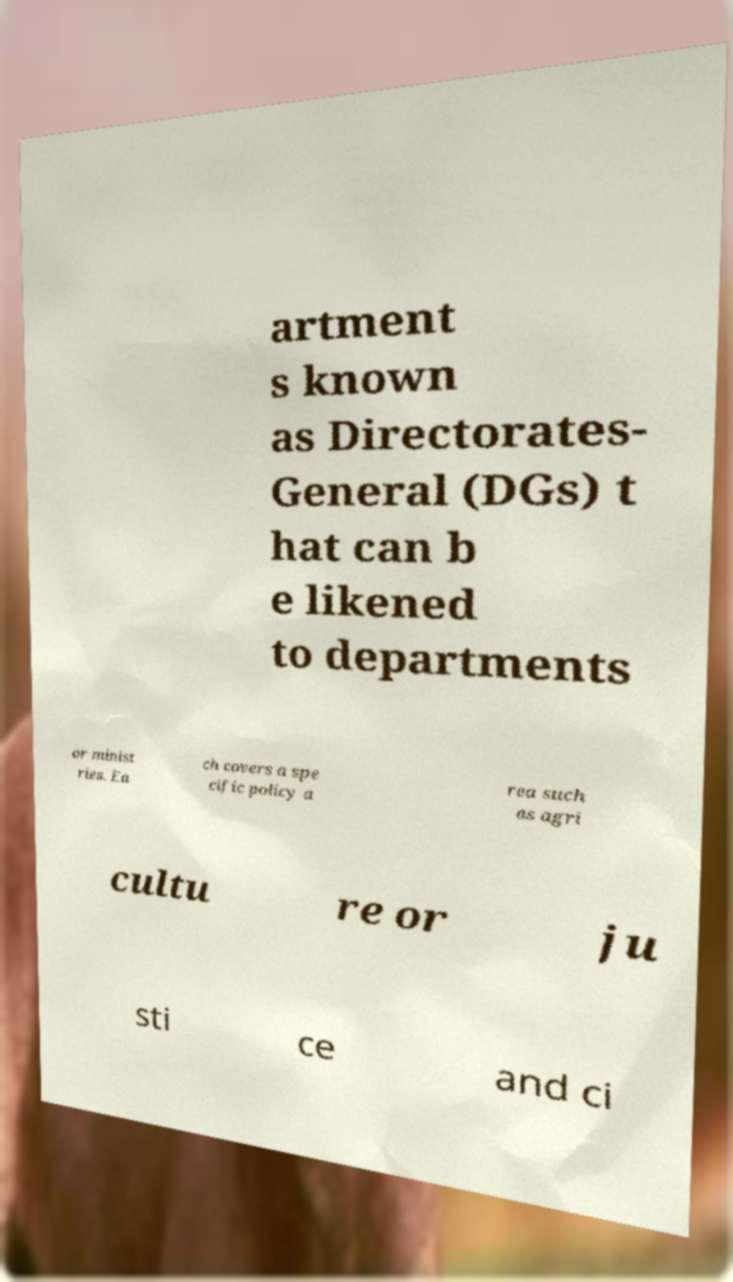Could you extract and type out the text from this image? artment s known as Directorates- General (DGs) t hat can b e likened to departments or minist ries. Ea ch covers a spe cific policy a rea such as agri cultu re or ju sti ce and ci 